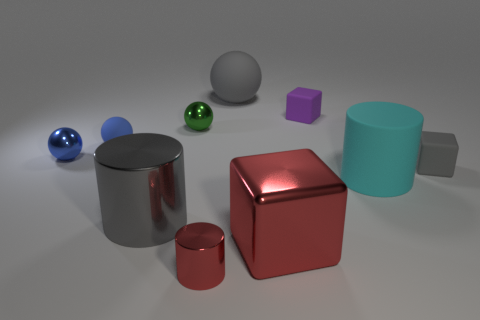Subtract all blocks. How many objects are left? 7 Subtract all big red metal cubes. Subtract all large cylinders. How many objects are left? 7 Add 6 small gray things. How many small gray things are left? 7 Add 2 small objects. How many small objects exist? 8 Subtract 0 blue cylinders. How many objects are left? 10 